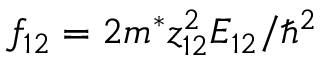Convert formula to latex. <formula><loc_0><loc_0><loc_500><loc_500>f _ { 1 2 } = 2 m ^ { * } z _ { 1 2 } ^ { 2 } E _ { 1 2 } / \hbar { ^ } { 2 }</formula> 